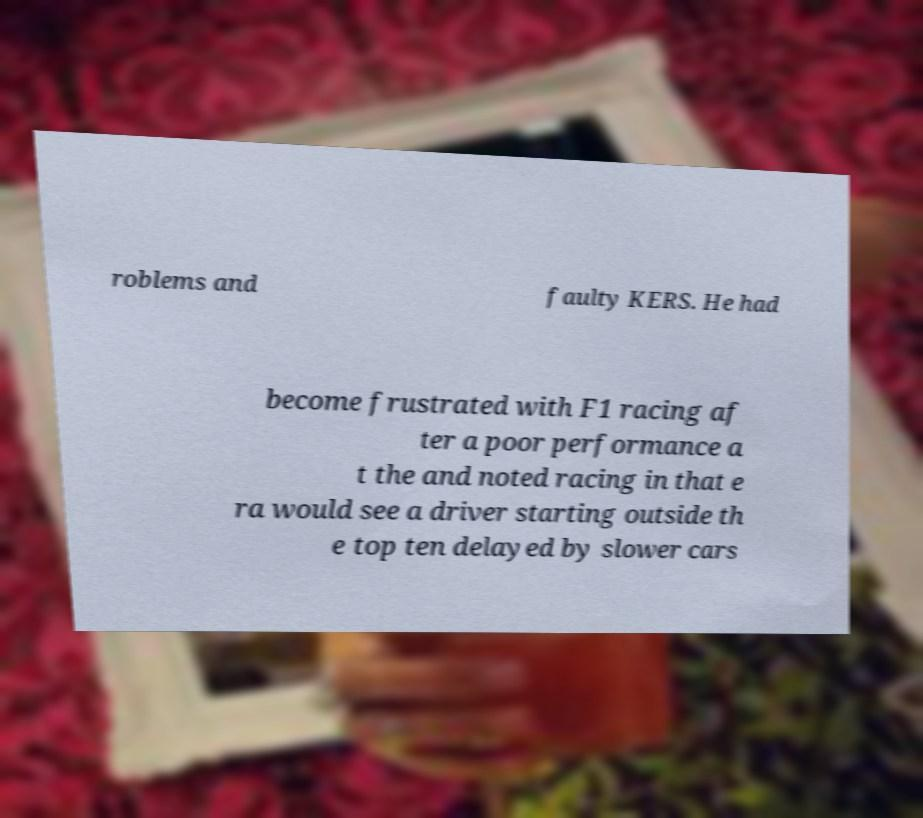Can you accurately transcribe the text from the provided image for me? roblems and faulty KERS. He had become frustrated with F1 racing af ter a poor performance a t the and noted racing in that e ra would see a driver starting outside th e top ten delayed by slower cars 